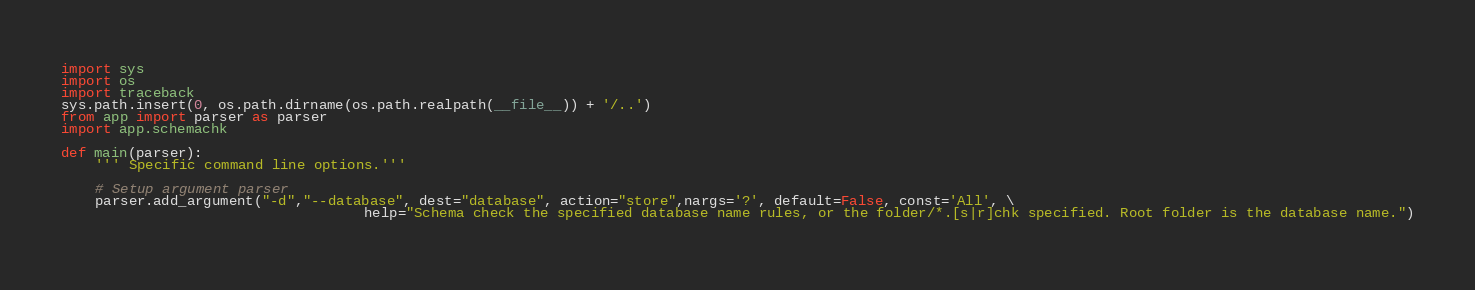Convert code to text. <code><loc_0><loc_0><loc_500><loc_500><_Python_>import sys
import os
import traceback
sys.path.insert(0, os.path.dirname(os.path.realpath(__file__)) + '/..')
from app import parser as parser
import app.schemachk

def main(parser):
    ''' Specific command line options.'''

    # Setup argument parser
    parser.add_argument("-d","--database", dest="database", action="store",nargs='?', default=False, const='All', \
                                    help="Schema check the specified database name rules, or the folder/*.[s|r]chk specified. Root folder is the database name.")
    </code> 